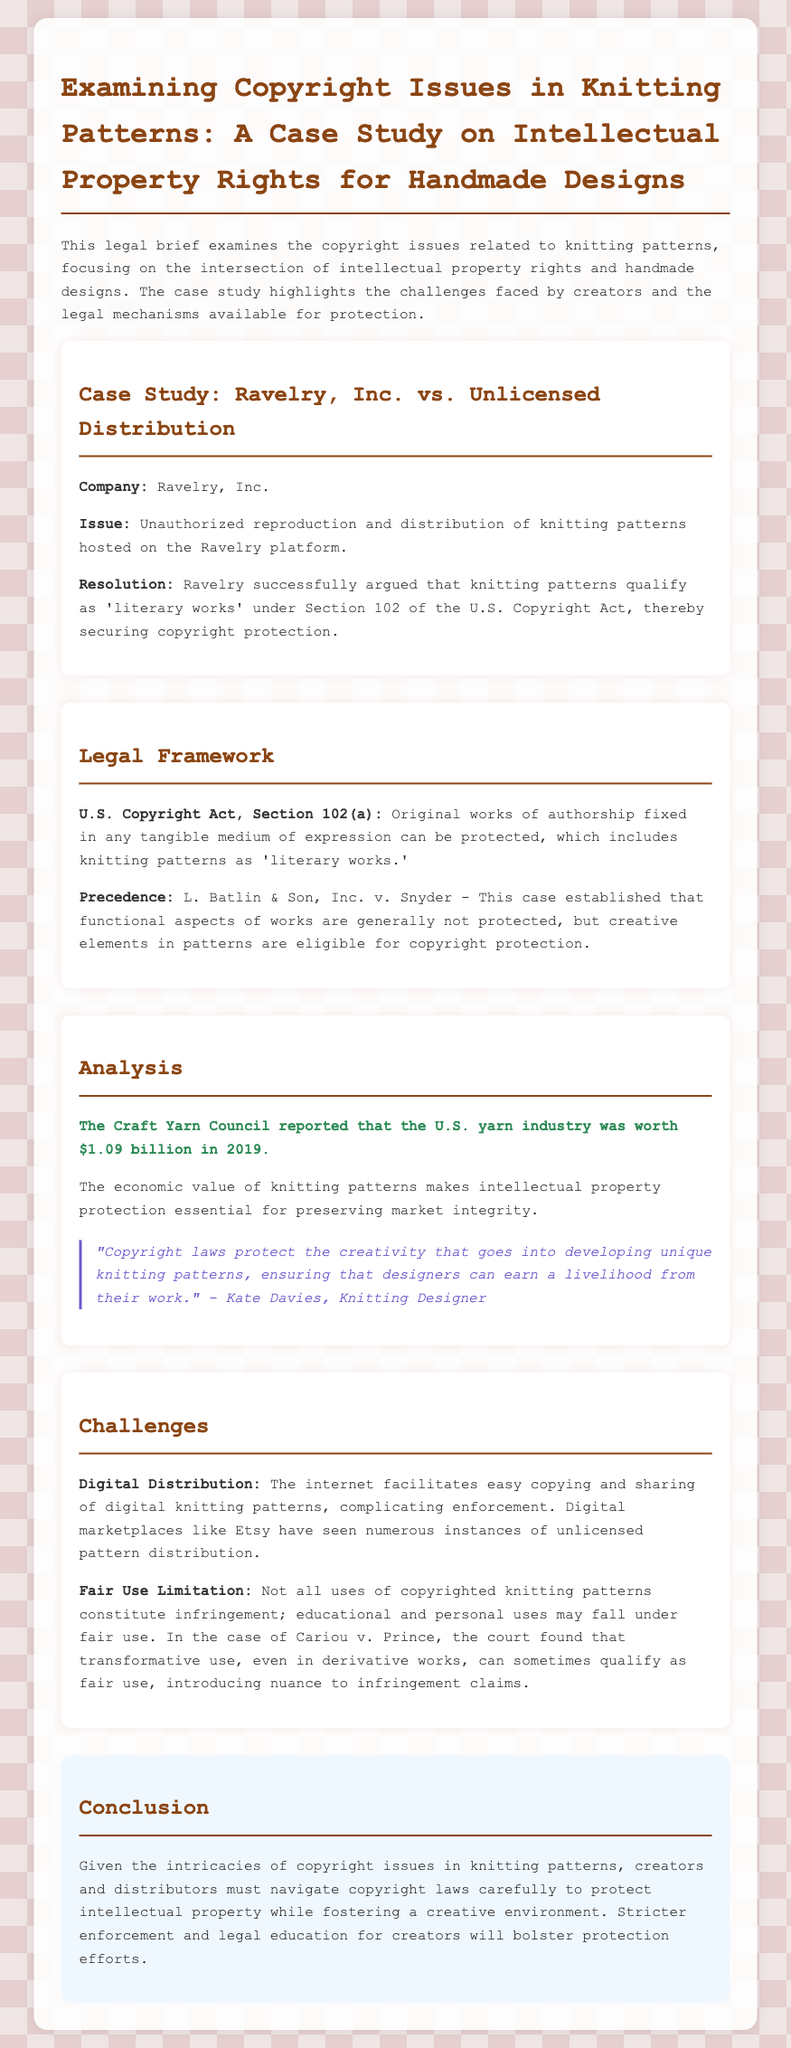What is the company involved in the case study? The company involved in the case study is identified as Ravelry, Inc.
Answer: Ravelry, Inc What issue did Ravelry, Inc. face? The issue faced by Ravelry, Inc. was unauthorized reproduction and distribution of knitting patterns.
Answer: Unauthorized reproduction and distribution of knitting patterns What section of the U.S. Copyright Act protects knitting patterns? Knitting patterns qualify for protection under Section 102 of the U.S. Copyright Act, which addresses original works of authorship.
Answer: Section 102 What was the reported worth of the U.S. yarn industry in 2019? The document states that the economic value of the yarn industry was reported as $1.09 billion in 2019.
Answer: $1.09 billion Who is quoted regarding copyright laws protecting creativity in knitting? The quote is attributed to Kate Davies, who is a knitting designer.
Answer: Kate Davies What legal precedent is referenced regarding the protection of creative elements in patterns? The case L. Batlin & Son, Inc. v. Snyder is referenced regarding the protection of creative elements in patterns.
Answer: L. Batlin & Son, Inc. v. Snyder What digital marketplace is mentioned in relation to unlicensed pattern distribution? The document mentions Etsy as a digital marketplace where unlicensed pattern distribution has occurred.
Answer: Etsy What challenge does digital distribution pose for knitting pattern creators? The document indicates that digital distribution complicates enforcement of copyright laws due to easy copying and sharing.
Answer: Easy copying and sharing What is highlighted as a limitation in copyright protection for knitting patterns? The limitation highlighted is that not all uses of copyrighted patterns constitute infringement, particularly educational and personal uses.
Answer: Fair Use Limitation 